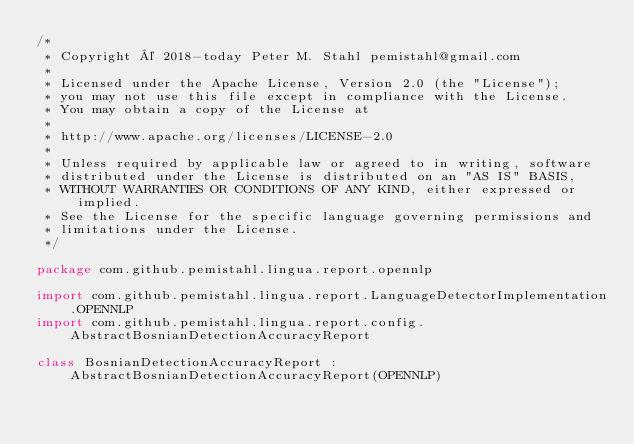Convert code to text. <code><loc_0><loc_0><loc_500><loc_500><_Kotlin_>/*
 * Copyright © 2018-today Peter M. Stahl pemistahl@gmail.com
 *
 * Licensed under the Apache License, Version 2.0 (the "License");
 * you may not use this file except in compliance with the License.
 * You may obtain a copy of the License at
 *
 * http://www.apache.org/licenses/LICENSE-2.0
 *
 * Unless required by applicable law or agreed to in writing, software
 * distributed under the License is distributed on an "AS IS" BASIS,
 * WITHOUT WARRANTIES OR CONDITIONS OF ANY KIND, either expressed or implied.
 * See the License for the specific language governing permissions and
 * limitations under the License.
 */

package com.github.pemistahl.lingua.report.opennlp

import com.github.pemistahl.lingua.report.LanguageDetectorImplementation.OPENNLP
import com.github.pemistahl.lingua.report.config.AbstractBosnianDetectionAccuracyReport

class BosnianDetectionAccuracyReport : AbstractBosnianDetectionAccuracyReport(OPENNLP)
</code> 